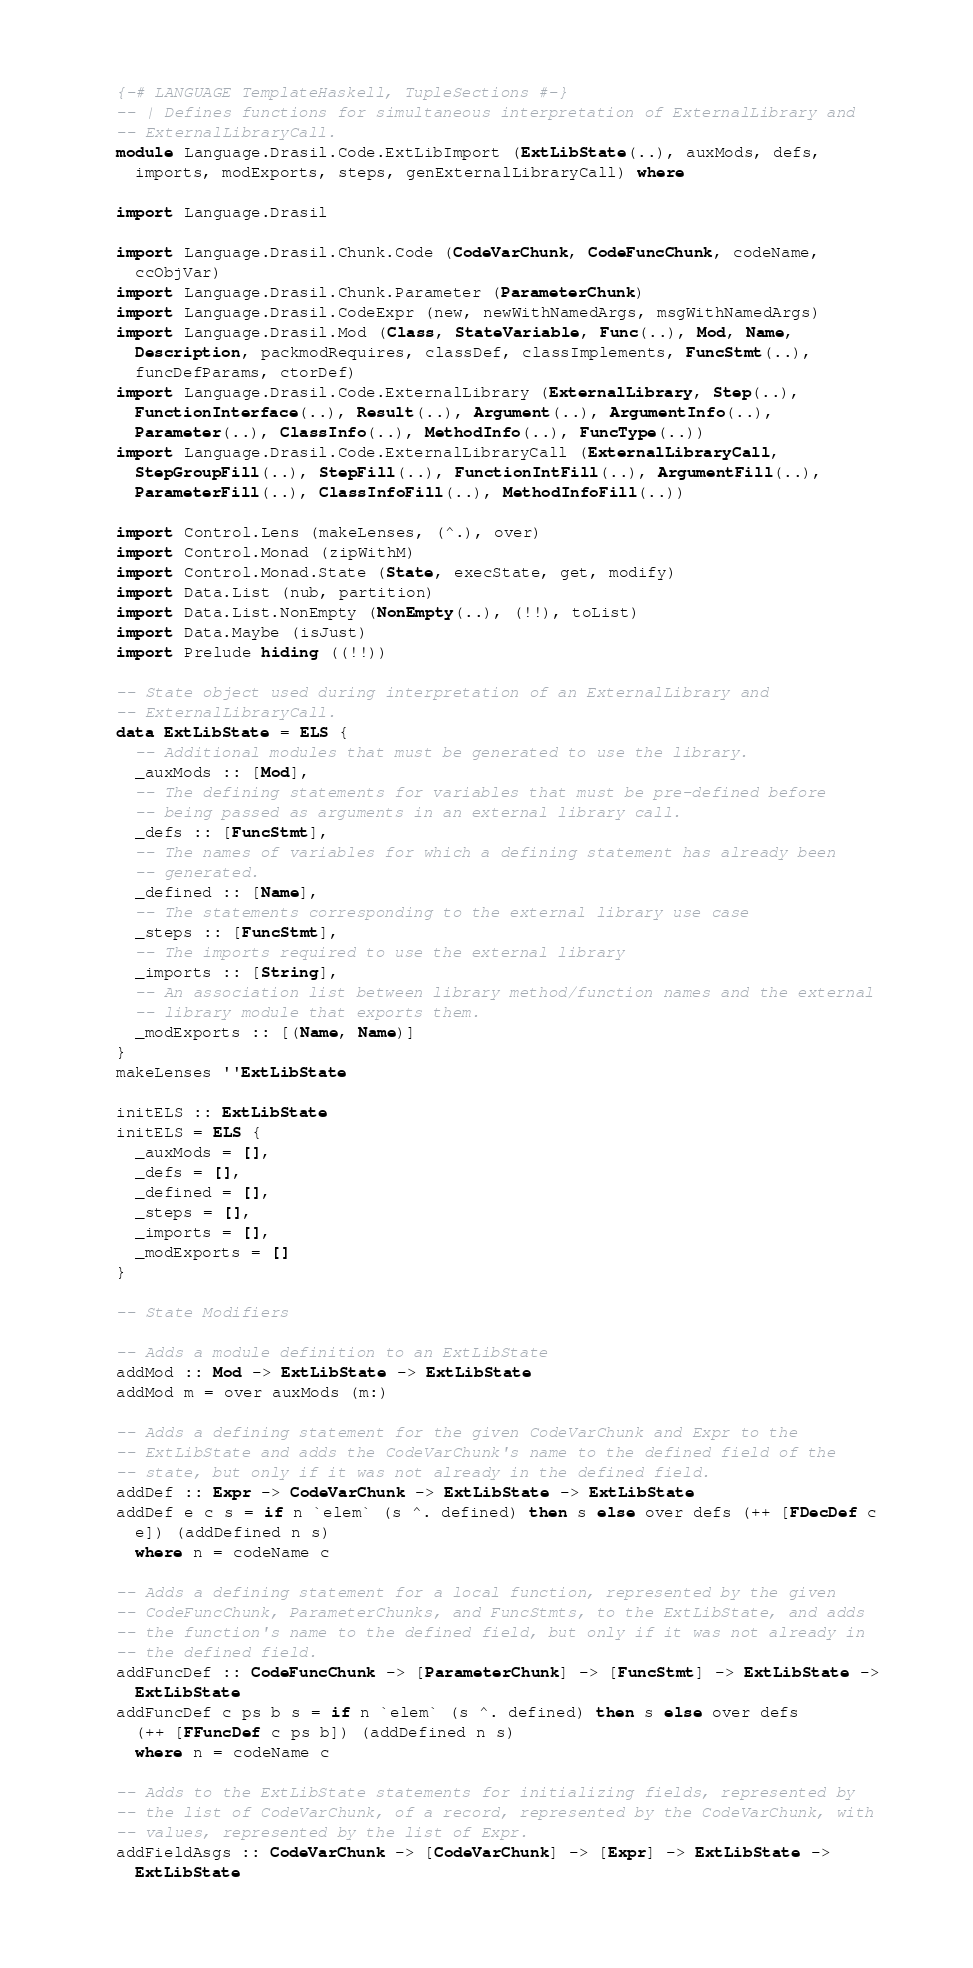<code> <loc_0><loc_0><loc_500><loc_500><_Haskell_>{-# LANGUAGE TemplateHaskell, TupleSections #-}
-- | Defines functions for simultaneous interpretation of ExternalLibrary and 
-- ExternalLibraryCall.
module Language.Drasil.Code.ExtLibImport (ExtLibState(..), auxMods, defs, 
  imports, modExports, steps, genExternalLibraryCall) where

import Language.Drasil

import Language.Drasil.Chunk.Code (CodeVarChunk, CodeFuncChunk, codeName, 
  ccObjVar)
import Language.Drasil.Chunk.Parameter (ParameterChunk)
import Language.Drasil.CodeExpr (new, newWithNamedArgs, msgWithNamedArgs)
import Language.Drasil.Mod (Class, StateVariable, Func(..), Mod, Name, 
  Description, packmodRequires, classDef, classImplements, FuncStmt(..), 
  funcDefParams, ctorDef)
import Language.Drasil.Code.ExternalLibrary (ExternalLibrary, Step(..), 
  FunctionInterface(..), Result(..), Argument(..), ArgumentInfo(..), 
  Parameter(..), ClassInfo(..), MethodInfo(..), FuncType(..))
import Language.Drasil.Code.ExternalLibraryCall (ExternalLibraryCall,
  StepGroupFill(..), StepFill(..), FunctionIntFill(..), ArgumentFill(..),
  ParameterFill(..), ClassInfoFill(..), MethodInfoFill(..))

import Control.Lens (makeLenses, (^.), over)
import Control.Monad (zipWithM)
import Control.Monad.State (State, execState, get, modify)
import Data.List (nub, partition)
import Data.List.NonEmpty (NonEmpty(..), (!!), toList)
import Data.Maybe (isJust)
import Prelude hiding ((!!))

-- State object used during interpretation of an ExternalLibrary and 
-- ExternalLibraryCall.
data ExtLibState = ELS {
  -- Additional modules that must be generated to use the library.
  _auxMods :: [Mod], 
  -- The defining statements for variables that must be pre-defined before 
  -- being passed as arguments in an external library call.
  _defs :: [FuncStmt],
  -- The names of variables for which a defining statement has already been 
  -- generated. 
  _defined :: [Name], 
  -- The statements corresponding to the external library use case
  _steps :: [FuncStmt],
  -- The imports required to use the external library
  _imports :: [String],
  -- An association list between library method/function names and the external 
  -- library module that exports them.
  _modExports :: [(Name, Name)]
}
makeLenses ''ExtLibState

initELS :: ExtLibState
initELS = ELS {
  _auxMods = [],
  _defs = [],
  _defined = [],
  _steps = [],
  _imports = [],
  _modExports = []
}

-- State Modifiers

-- Adds a module definition to an ExtLibState
addMod :: Mod -> ExtLibState -> ExtLibState
addMod m = over auxMods (m:)

-- Adds a defining statement for the given CodeVarChunk and Expr to the 
-- ExtLibState and adds the CodeVarChunk's name to the defined field of the 
-- state, but only if it was not already in the defined field. 
addDef :: Expr -> CodeVarChunk -> ExtLibState -> ExtLibState
addDef e c s = if n `elem` (s ^. defined) then s else over defs (++ [FDecDef c 
  e]) (addDefined n s)
  where n = codeName c

-- Adds a defining statement for a local function, represented by the given 
-- CodeFuncChunk, ParameterChunks, and FuncStmts, to the ExtLibState, and adds
-- the function's name to the defined field, but only if it was not already in
-- the defined field.
addFuncDef :: CodeFuncChunk -> [ParameterChunk] -> [FuncStmt] -> ExtLibState -> 
  ExtLibState
addFuncDef c ps b s = if n `elem` (s ^. defined) then s else over defs 
  (++ [FFuncDef c ps b]) (addDefined n s)
  where n = codeName c

-- Adds to the ExtLibState statements for initializing fields, represented by 
-- the list of CodeVarChunk, of a record, represented by the CodeVarChunk, with 
-- values, represented by the list of Expr.
addFieldAsgs :: CodeVarChunk -> [CodeVarChunk] -> [Expr] -> ExtLibState -> 
  ExtLibState</code> 